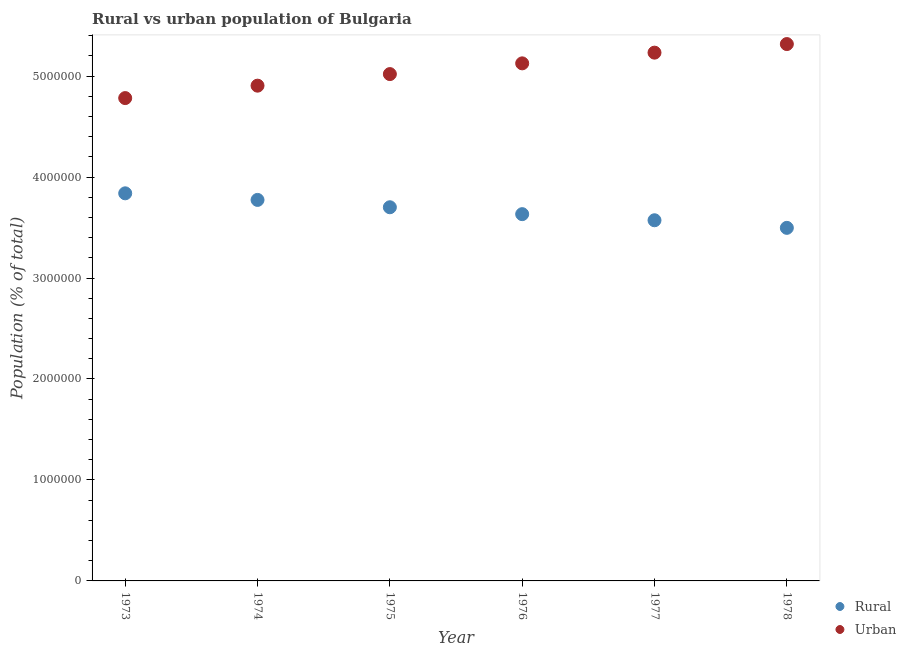Is the number of dotlines equal to the number of legend labels?
Make the answer very short. Yes. What is the urban population density in 1978?
Ensure brevity in your answer.  5.32e+06. Across all years, what is the maximum urban population density?
Make the answer very short. 5.32e+06. Across all years, what is the minimum urban population density?
Keep it short and to the point. 4.78e+06. In which year was the urban population density maximum?
Keep it short and to the point. 1978. In which year was the urban population density minimum?
Ensure brevity in your answer.  1973. What is the total rural population density in the graph?
Keep it short and to the point. 2.20e+07. What is the difference between the urban population density in 1977 and that in 1978?
Provide a succinct answer. -8.50e+04. What is the difference between the urban population density in 1978 and the rural population density in 1973?
Provide a short and direct response. 1.48e+06. What is the average rural population density per year?
Offer a terse response. 3.67e+06. In the year 1973, what is the difference between the rural population density and urban population density?
Offer a terse response. -9.43e+05. In how many years, is the urban population density greater than 400000 %?
Your response must be concise. 6. What is the ratio of the urban population density in 1975 to that in 1976?
Give a very brief answer. 0.98. Is the difference between the urban population density in 1977 and 1978 greater than the difference between the rural population density in 1977 and 1978?
Offer a terse response. No. What is the difference between the highest and the second highest rural population density?
Provide a succinct answer. 6.52e+04. What is the difference between the highest and the lowest urban population density?
Ensure brevity in your answer.  5.35e+05. Is the sum of the rural population density in 1973 and 1974 greater than the maximum urban population density across all years?
Your answer should be very brief. Yes. Is the rural population density strictly greater than the urban population density over the years?
Give a very brief answer. No. How many years are there in the graph?
Keep it short and to the point. 6. Are the values on the major ticks of Y-axis written in scientific E-notation?
Your answer should be very brief. No. Does the graph contain grids?
Provide a succinct answer. No. Where does the legend appear in the graph?
Your response must be concise. Bottom right. How many legend labels are there?
Give a very brief answer. 2. What is the title of the graph?
Your answer should be compact. Rural vs urban population of Bulgaria. What is the label or title of the X-axis?
Your answer should be very brief. Year. What is the label or title of the Y-axis?
Provide a succinct answer. Population (% of total). What is the Population (% of total) in Rural in 1973?
Your response must be concise. 3.84e+06. What is the Population (% of total) of Urban in 1973?
Ensure brevity in your answer.  4.78e+06. What is the Population (% of total) in Rural in 1974?
Provide a short and direct response. 3.77e+06. What is the Population (% of total) in Urban in 1974?
Your answer should be compact. 4.91e+06. What is the Population (% of total) of Rural in 1975?
Make the answer very short. 3.70e+06. What is the Population (% of total) of Urban in 1975?
Make the answer very short. 5.02e+06. What is the Population (% of total) of Rural in 1976?
Your answer should be compact. 3.63e+06. What is the Population (% of total) in Urban in 1976?
Your answer should be compact. 5.13e+06. What is the Population (% of total) in Rural in 1977?
Provide a short and direct response. 3.57e+06. What is the Population (% of total) of Urban in 1977?
Offer a terse response. 5.23e+06. What is the Population (% of total) in Rural in 1978?
Offer a very short reply. 3.50e+06. What is the Population (% of total) in Urban in 1978?
Provide a succinct answer. 5.32e+06. Across all years, what is the maximum Population (% of total) in Rural?
Provide a short and direct response. 3.84e+06. Across all years, what is the maximum Population (% of total) in Urban?
Give a very brief answer. 5.32e+06. Across all years, what is the minimum Population (% of total) in Rural?
Make the answer very short. 3.50e+06. Across all years, what is the minimum Population (% of total) in Urban?
Offer a very short reply. 4.78e+06. What is the total Population (% of total) of Rural in the graph?
Provide a short and direct response. 2.20e+07. What is the total Population (% of total) of Urban in the graph?
Offer a terse response. 3.04e+07. What is the difference between the Population (% of total) in Rural in 1973 and that in 1974?
Make the answer very short. 6.52e+04. What is the difference between the Population (% of total) of Urban in 1973 and that in 1974?
Your response must be concise. -1.23e+05. What is the difference between the Population (% of total) in Rural in 1973 and that in 1975?
Your answer should be compact. 1.38e+05. What is the difference between the Population (% of total) in Urban in 1973 and that in 1975?
Offer a terse response. -2.38e+05. What is the difference between the Population (% of total) in Rural in 1973 and that in 1976?
Provide a short and direct response. 2.06e+05. What is the difference between the Population (% of total) of Urban in 1973 and that in 1976?
Your response must be concise. -3.44e+05. What is the difference between the Population (% of total) of Rural in 1973 and that in 1977?
Offer a terse response. 2.67e+05. What is the difference between the Population (% of total) in Urban in 1973 and that in 1977?
Offer a very short reply. -4.50e+05. What is the difference between the Population (% of total) of Rural in 1973 and that in 1978?
Your answer should be very brief. 3.42e+05. What is the difference between the Population (% of total) in Urban in 1973 and that in 1978?
Keep it short and to the point. -5.35e+05. What is the difference between the Population (% of total) in Rural in 1974 and that in 1975?
Provide a short and direct response. 7.27e+04. What is the difference between the Population (% of total) of Urban in 1974 and that in 1975?
Provide a succinct answer. -1.15e+05. What is the difference between the Population (% of total) of Rural in 1974 and that in 1976?
Offer a terse response. 1.41e+05. What is the difference between the Population (% of total) of Urban in 1974 and that in 1976?
Provide a succinct answer. -2.21e+05. What is the difference between the Population (% of total) of Rural in 1974 and that in 1977?
Offer a terse response. 2.02e+05. What is the difference between the Population (% of total) in Urban in 1974 and that in 1977?
Your answer should be very brief. -3.27e+05. What is the difference between the Population (% of total) in Rural in 1974 and that in 1978?
Offer a terse response. 2.77e+05. What is the difference between the Population (% of total) in Urban in 1974 and that in 1978?
Provide a short and direct response. -4.12e+05. What is the difference between the Population (% of total) in Rural in 1975 and that in 1976?
Keep it short and to the point. 6.84e+04. What is the difference between the Population (% of total) of Urban in 1975 and that in 1976?
Your response must be concise. -1.06e+05. What is the difference between the Population (% of total) of Rural in 1975 and that in 1977?
Your response must be concise. 1.29e+05. What is the difference between the Population (% of total) of Urban in 1975 and that in 1977?
Provide a succinct answer. -2.12e+05. What is the difference between the Population (% of total) in Rural in 1975 and that in 1978?
Provide a short and direct response. 2.04e+05. What is the difference between the Population (% of total) in Urban in 1975 and that in 1978?
Your answer should be compact. -2.97e+05. What is the difference between the Population (% of total) in Rural in 1976 and that in 1977?
Your response must be concise. 6.05e+04. What is the difference between the Population (% of total) in Urban in 1976 and that in 1977?
Offer a terse response. -1.06e+05. What is the difference between the Population (% of total) in Rural in 1976 and that in 1978?
Keep it short and to the point. 1.36e+05. What is the difference between the Population (% of total) in Urban in 1976 and that in 1978?
Offer a terse response. -1.91e+05. What is the difference between the Population (% of total) in Rural in 1977 and that in 1978?
Make the answer very short. 7.52e+04. What is the difference between the Population (% of total) of Urban in 1977 and that in 1978?
Keep it short and to the point. -8.50e+04. What is the difference between the Population (% of total) of Rural in 1973 and the Population (% of total) of Urban in 1974?
Make the answer very short. -1.07e+06. What is the difference between the Population (% of total) of Rural in 1973 and the Population (% of total) of Urban in 1975?
Provide a short and direct response. -1.18e+06. What is the difference between the Population (% of total) of Rural in 1973 and the Population (% of total) of Urban in 1976?
Provide a succinct answer. -1.29e+06. What is the difference between the Population (% of total) in Rural in 1973 and the Population (% of total) in Urban in 1977?
Your answer should be very brief. -1.39e+06. What is the difference between the Population (% of total) in Rural in 1973 and the Population (% of total) in Urban in 1978?
Offer a terse response. -1.48e+06. What is the difference between the Population (% of total) of Rural in 1974 and the Population (% of total) of Urban in 1975?
Ensure brevity in your answer.  -1.25e+06. What is the difference between the Population (% of total) of Rural in 1974 and the Population (% of total) of Urban in 1976?
Provide a succinct answer. -1.35e+06. What is the difference between the Population (% of total) of Rural in 1974 and the Population (% of total) of Urban in 1977?
Keep it short and to the point. -1.46e+06. What is the difference between the Population (% of total) in Rural in 1974 and the Population (% of total) in Urban in 1978?
Offer a terse response. -1.54e+06. What is the difference between the Population (% of total) in Rural in 1975 and the Population (% of total) in Urban in 1976?
Offer a terse response. -1.43e+06. What is the difference between the Population (% of total) of Rural in 1975 and the Population (% of total) of Urban in 1977?
Your response must be concise. -1.53e+06. What is the difference between the Population (% of total) in Rural in 1975 and the Population (% of total) in Urban in 1978?
Your response must be concise. -1.62e+06. What is the difference between the Population (% of total) in Rural in 1976 and the Population (% of total) in Urban in 1977?
Your response must be concise. -1.60e+06. What is the difference between the Population (% of total) in Rural in 1976 and the Population (% of total) in Urban in 1978?
Your answer should be compact. -1.68e+06. What is the difference between the Population (% of total) in Rural in 1977 and the Population (% of total) in Urban in 1978?
Your response must be concise. -1.75e+06. What is the average Population (% of total) of Rural per year?
Give a very brief answer. 3.67e+06. What is the average Population (% of total) of Urban per year?
Keep it short and to the point. 5.06e+06. In the year 1973, what is the difference between the Population (% of total) in Rural and Population (% of total) in Urban?
Provide a short and direct response. -9.43e+05. In the year 1974, what is the difference between the Population (% of total) in Rural and Population (% of total) in Urban?
Give a very brief answer. -1.13e+06. In the year 1975, what is the difference between the Population (% of total) in Rural and Population (% of total) in Urban?
Your answer should be very brief. -1.32e+06. In the year 1976, what is the difference between the Population (% of total) of Rural and Population (% of total) of Urban?
Your answer should be compact. -1.49e+06. In the year 1977, what is the difference between the Population (% of total) of Rural and Population (% of total) of Urban?
Your response must be concise. -1.66e+06. In the year 1978, what is the difference between the Population (% of total) of Rural and Population (% of total) of Urban?
Provide a succinct answer. -1.82e+06. What is the ratio of the Population (% of total) in Rural in 1973 to that in 1974?
Provide a succinct answer. 1.02. What is the ratio of the Population (% of total) of Urban in 1973 to that in 1974?
Ensure brevity in your answer.  0.97. What is the ratio of the Population (% of total) of Rural in 1973 to that in 1975?
Offer a terse response. 1.04. What is the ratio of the Population (% of total) of Urban in 1973 to that in 1975?
Your answer should be very brief. 0.95. What is the ratio of the Population (% of total) of Rural in 1973 to that in 1976?
Provide a short and direct response. 1.06. What is the ratio of the Population (% of total) in Urban in 1973 to that in 1976?
Give a very brief answer. 0.93. What is the ratio of the Population (% of total) in Rural in 1973 to that in 1977?
Make the answer very short. 1.07. What is the ratio of the Population (% of total) of Urban in 1973 to that in 1977?
Give a very brief answer. 0.91. What is the ratio of the Population (% of total) in Rural in 1973 to that in 1978?
Give a very brief answer. 1.1. What is the ratio of the Population (% of total) in Urban in 1973 to that in 1978?
Provide a short and direct response. 0.9. What is the ratio of the Population (% of total) in Rural in 1974 to that in 1975?
Your answer should be very brief. 1.02. What is the ratio of the Population (% of total) in Urban in 1974 to that in 1975?
Keep it short and to the point. 0.98. What is the ratio of the Population (% of total) of Rural in 1974 to that in 1976?
Your answer should be very brief. 1.04. What is the ratio of the Population (% of total) of Urban in 1974 to that in 1976?
Ensure brevity in your answer.  0.96. What is the ratio of the Population (% of total) in Rural in 1974 to that in 1977?
Provide a succinct answer. 1.06. What is the ratio of the Population (% of total) in Rural in 1974 to that in 1978?
Offer a terse response. 1.08. What is the ratio of the Population (% of total) of Urban in 1974 to that in 1978?
Give a very brief answer. 0.92. What is the ratio of the Population (% of total) of Rural in 1975 to that in 1976?
Keep it short and to the point. 1.02. What is the ratio of the Population (% of total) in Urban in 1975 to that in 1976?
Offer a very short reply. 0.98. What is the ratio of the Population (% of total) of Rural in 1975 to that in 1977?
Give a very brief answer. 1.04. What is the ratio of the Population (% of total) in Urban in 1975 to that in 1977?
Ensure brevity in your answer.  0.96. What is the ratio of the Population (% of total) of Rural in 1975 to that in 1978?
Your answer should be compact. 1.06. What is the ratio of the Population (% of total) of Urban in 1975 to that in 1978?
Provide a succinct answer. 0.94. What is the ratio of the Population (% of total) in Rural in 1976 to that in 1977?
Offer a very short reply. 1.02. What is the ratio of the Population (% of total) in Urban in 1976 to that in 1977?
Make the answer very short. 0.98. What is the ratio of the Population (% of total) of Rural in 1976 to that in 1978?
Provide a succinct answer. 1.04. What is the ratio of the Population (% of total) in Urban in 1976 to that in 1978?
Make the answer very short. 0.96. What is the ratio of the Population (% of total) in Rural in 1977 to that in 1978?
Ensure brevity in your answer.  1.02. What is the difference between the highest and the second highest Population (% of total) in Rural?
Provide a short and direct response. 6.52e+04. What is the difference between the highest and the second highest Population (% of total) in Urban?
Offer a very short reply. 8.50e+04. What is the difference between the highest and the lowest Population (% of total) in Rural?
Offer a very short reply. 3.42e+05. What is the difference between the highest and the lowest Population (% of total) in Urban?
Your answer should be very brief. 5.35e+05. 